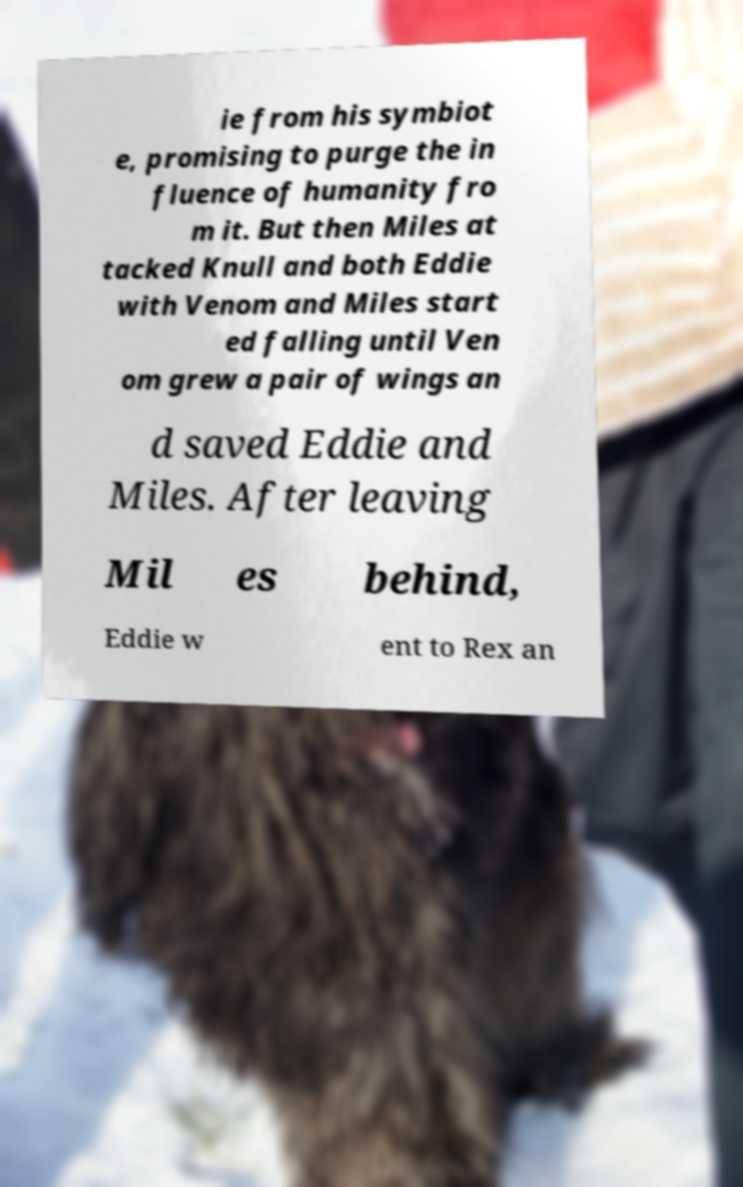What messages or text are displayed in this image? I need them in a readable, typed format. ie from his symbiot e, promising to purge the in fluence of humanity fro m it. But then Miles at tacked Knull and both Eddie with Venom and Miles start ed falling until Ven om grew a pair of wings an d saved Eddie and Miles. After leaving Mil es behind, Eddie w ent to Rex an 